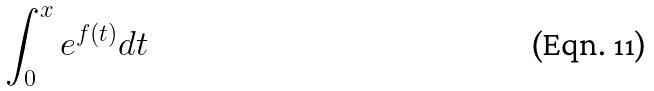Convert formula to latex. <formula><loc_0><loc_0><loc_500><loc_500>\int _ { 0 } ^ { x } e ^ { f ( t ) } d t</formula> 